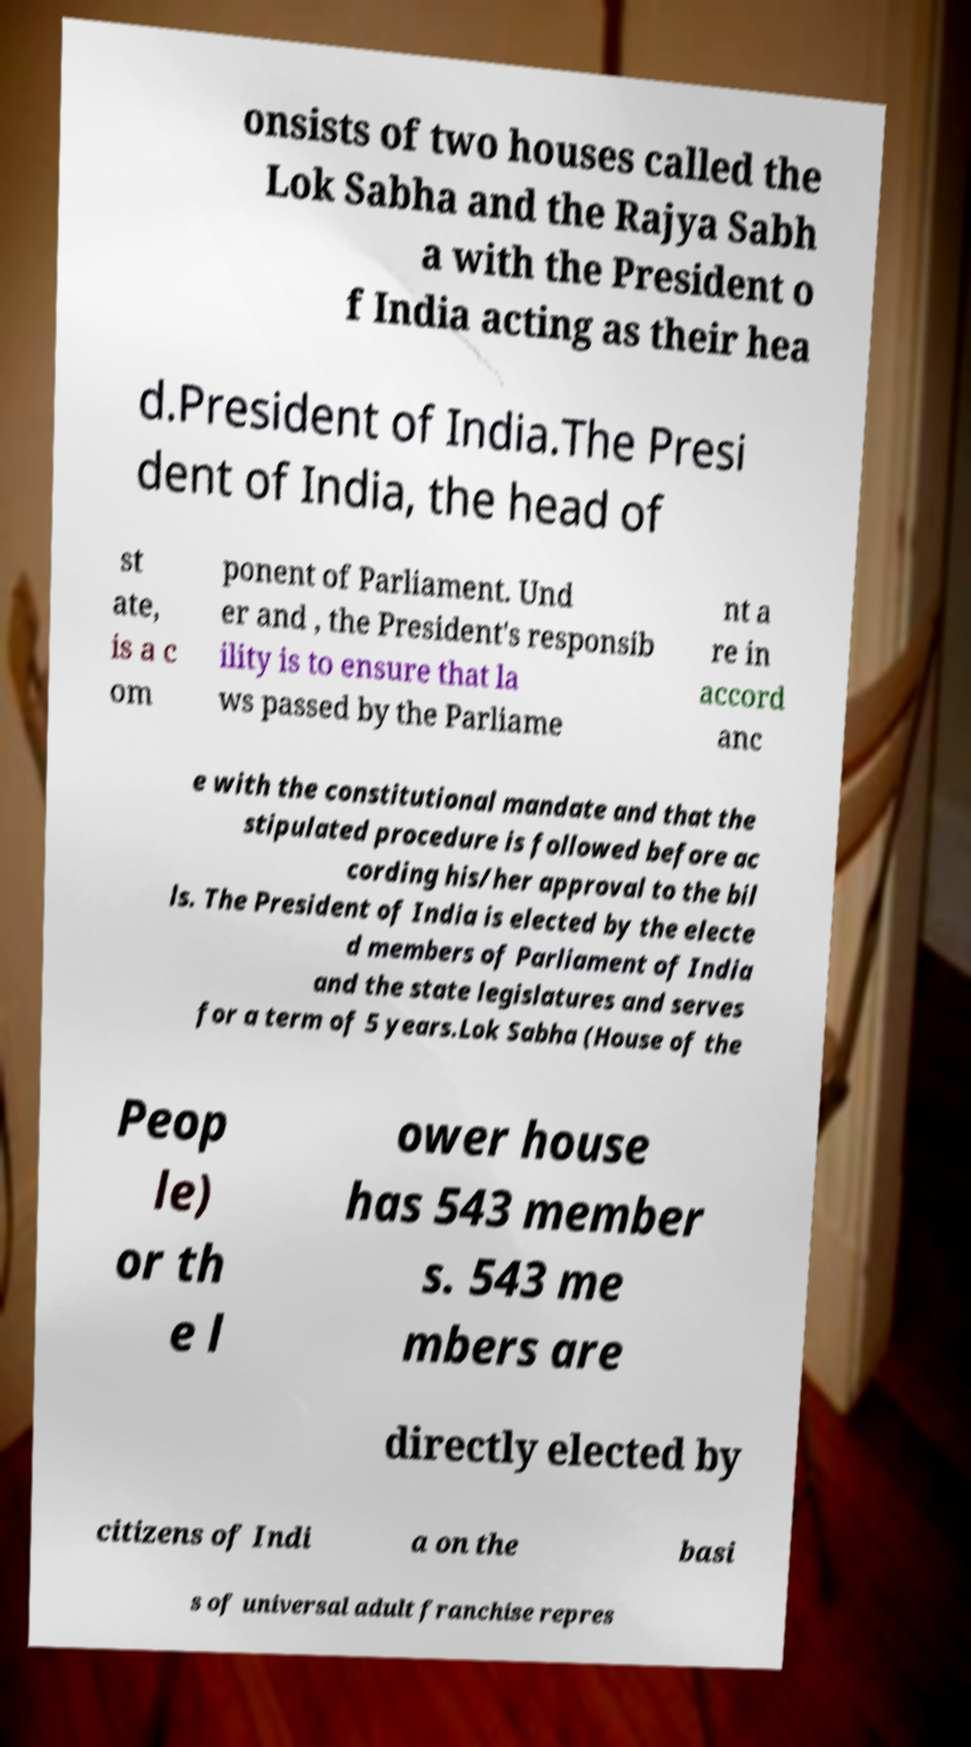There's text embedded in this image that I need extracted. Can you transcribe it verbatim? onsists of two houses called the Lok Sabha and the Rajya Sabh a with the President o f India acting as their hea d.President of India.The Presi dent of India, the head of st ate, is a c om ponent of Parliament. Und er and , the President's responsib ility is to ensure that la ws passed by the Parliame nt a re in accord anc e with the constitutional mandate and that the stipulated procedure is followed before ac cording his/her approval to the bil ls. The President of India is elected by the electe d members of Parliament of India and the state legislatures and serves for a term of 5 years.Lok Sabha (House of the Peop le) or th e l ower house has 543 member s. 543 me mbers are directly elected by citizens of Indi a on the basi s of universal adult franchise repres 